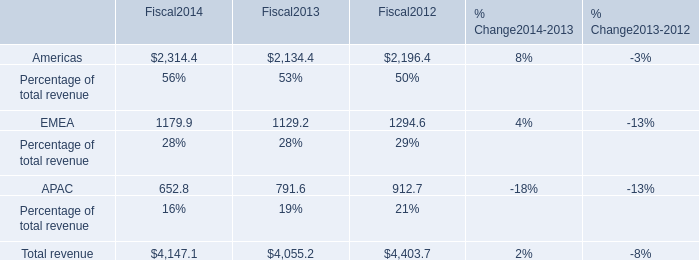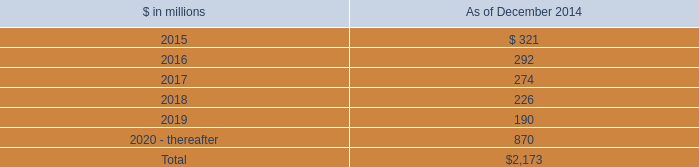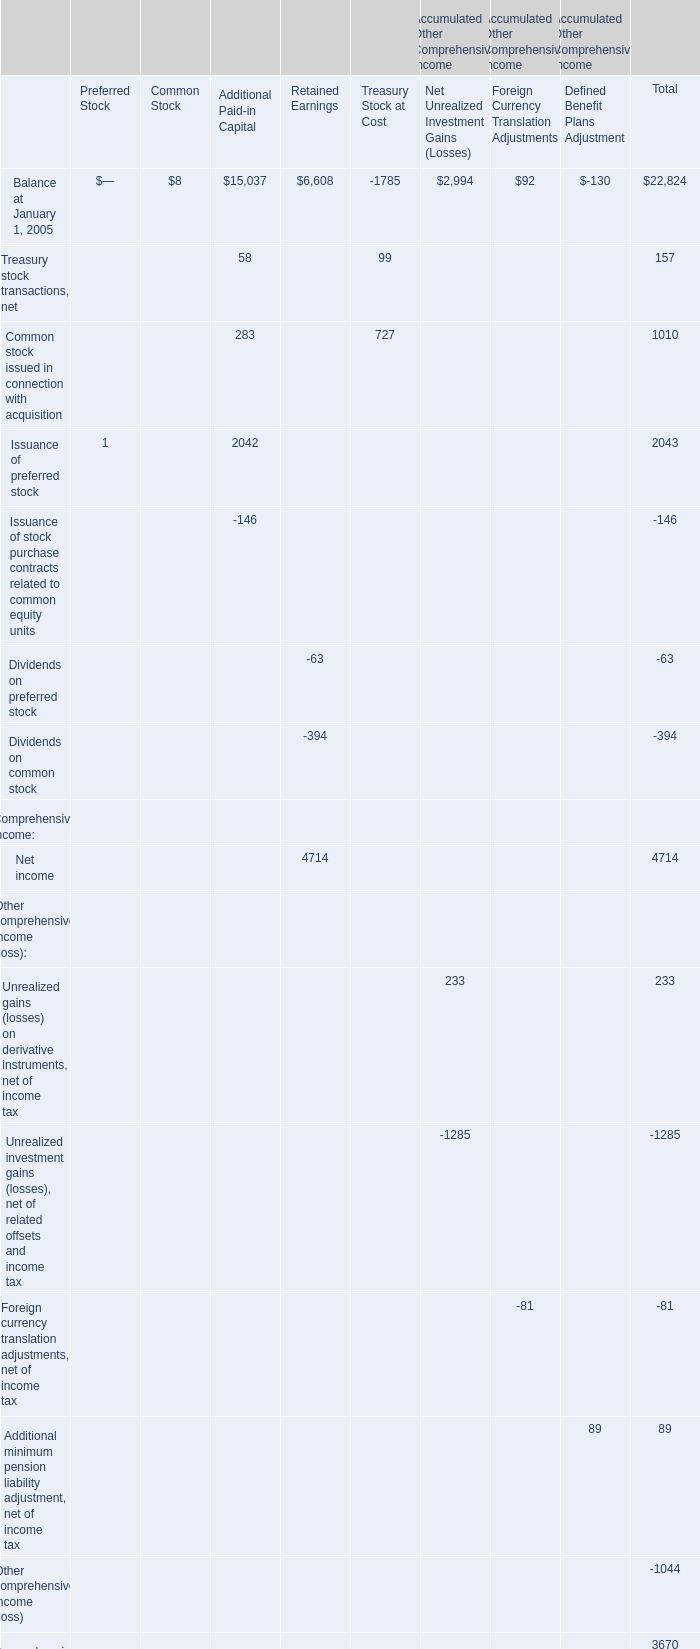At December 31,what year is the Balance for Retained Earnings greater than 19000? 
Answer: 2007. 